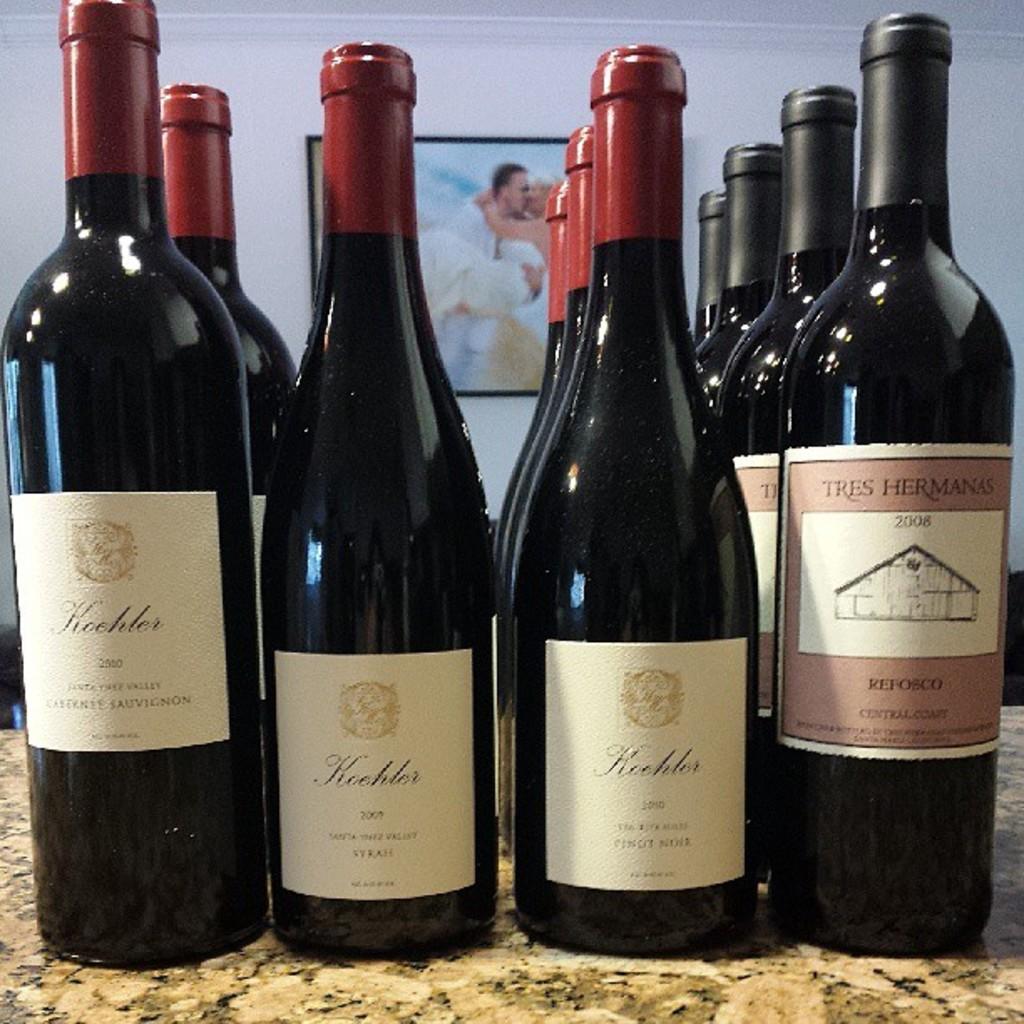What's the name of the bottle on the right?
Offer a terse response. Tres hermanas. 